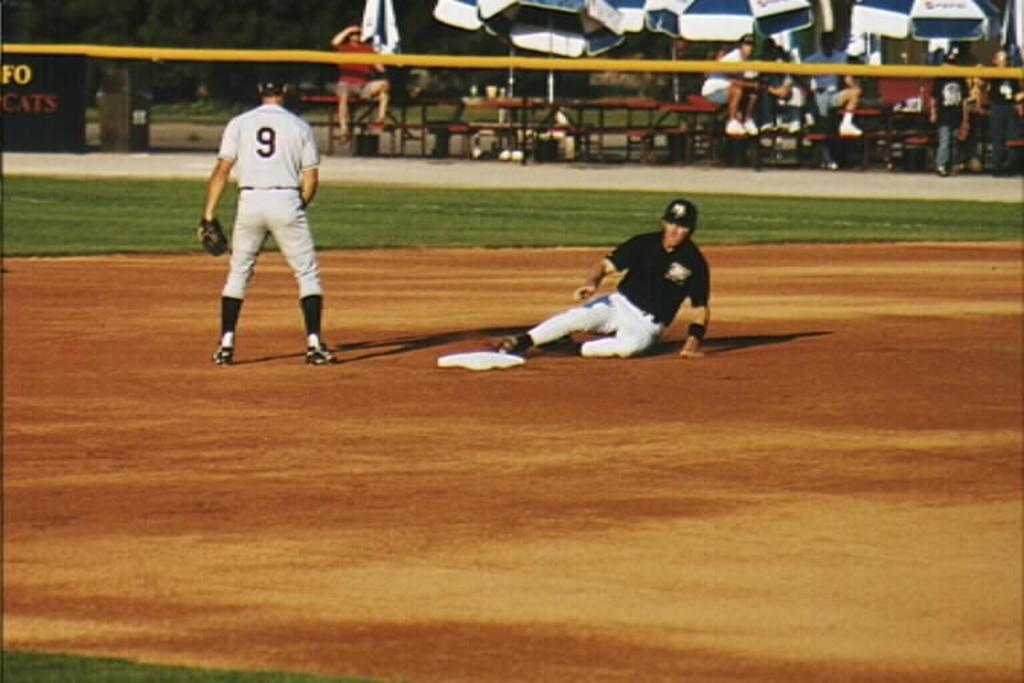<image>
Give a short and clear explanation of the subsequent image. a couple players on the baseball field with one wearing 9 